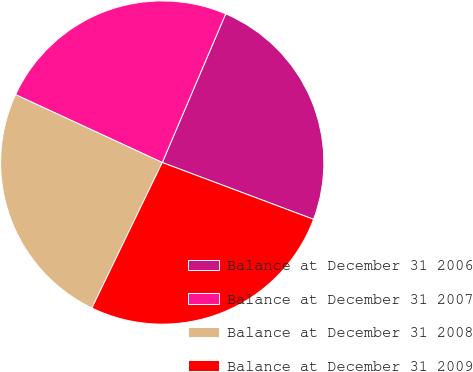<chart> <loc_0><loc_0><loc_500><loc_500><pie_chart><fcel>Balance at December 31 2006<fcel>Balance at December 31 2007<fcel>Balance at December 31 2008<fcel>Balance at December 31 2009<nl><fcel>24.3%<fcel>24.52%<fcel>24.73%<fcel>26.45%<nl></chart> 